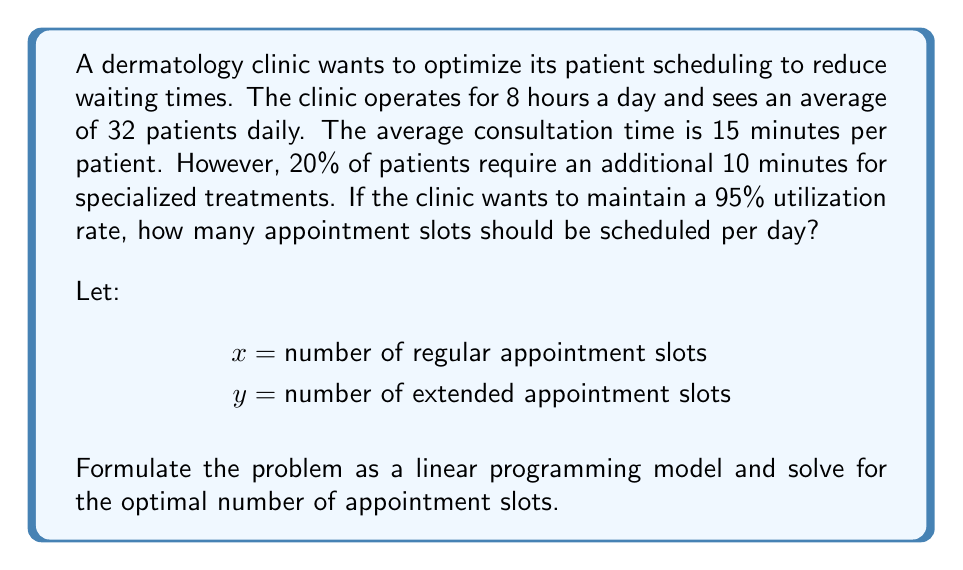Give your solution to this math problem. To solve this problem, we need to set up a linear programming model and solve it. Let's break it down step by step:

1. Define the objective function:
   We want to maximize the total number of appointments:
   $$ \text{Maximize } Z = x + y $$

2. Set up the constraints:
   a) Time constraint:
      Regular appointments take 15 minutes, extended appointments take 25 minutes.
      Total available time is 8 hours = 480 minutes.
      $$ 15x + 25y \leq 480 * 0.95 = 456 \text{ (95% utilization)} $$

   b) Patient distribution constraint:
      20% of patients require extended appointments.
      $$ y = 0.2(x + y) $$
      $$ y = 0.25x $$

3. Non-negativity constraints:
   $$ x \geq 0, y \geq 0 $$

4. Solve the system of equations:
   Substitute $y = 0.25x$ into the time constraint:
   $$ 15x + 25(0.25x) \leq 456 $$
   $$ 15x + 6.25x \leq 456 $$
   $$ 21.25x \leq 456 $$
   $$ x \leq 21.46 $$

   Since $x$ must be an integer, we round down:
   $$ x = 21 $$

   Calculate $y$:
   $$ y = 0.25x = 0.25 * 21 = 5.25 $$
   Rounding to the nearest integer:
   $$ y = 5 $$

5. Check the solution:
   Total time used: $21 * 15 + 5 * 25 = 440$ minutes
   Utilization rate: $440 / 480 = 91.67\%$, which is below the 95% limit.

Therefore, the optimal number of appointment slots is 21 regular slots and 5 extended slots, for a total of 26 slots.
Answer: The dermatology clinic should schedule 26 appointment slots per day: 21 regular slots and 5 extended slots. 